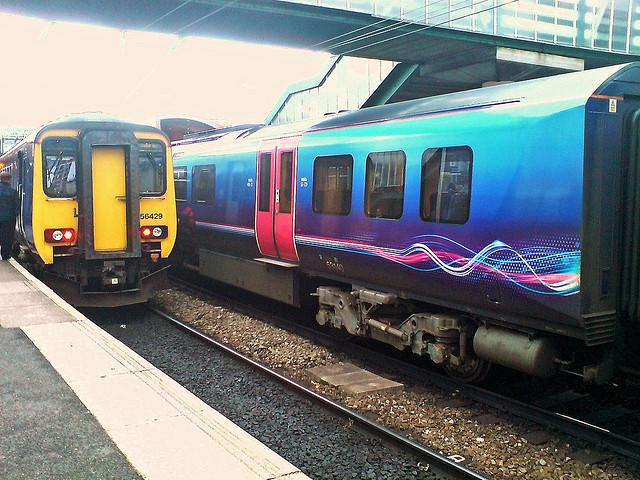What structure is present above the parked trains on the rail tracks?

Choices:
A) passenger walkway
B) parking garage
C) electric line
D) waiting area passenger walkway 